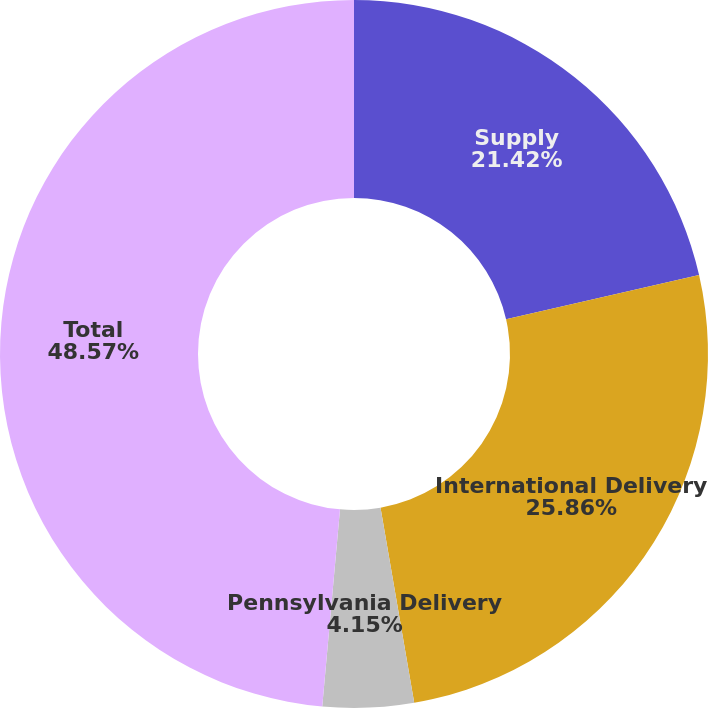Convert chart to OTSL. <chart><loc_0><loc_0><loc_500><loc_500><pie_chart><fcel>Supply<fcel>International Delivery<fcel>Pennsylvania Delivery<fcel>Total<nl><fcel>21.42%<fcel>25.86%<fcel>4.15%<fcel>48.57%<nl></chart> 